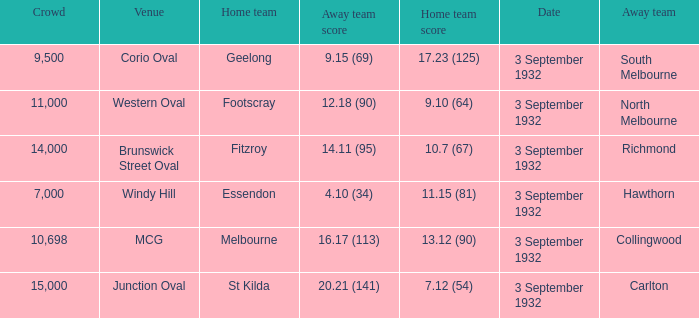What is the name of the Venue for the team that has an Away team score of 14.11 (95)? Brunswick Street Oval. 